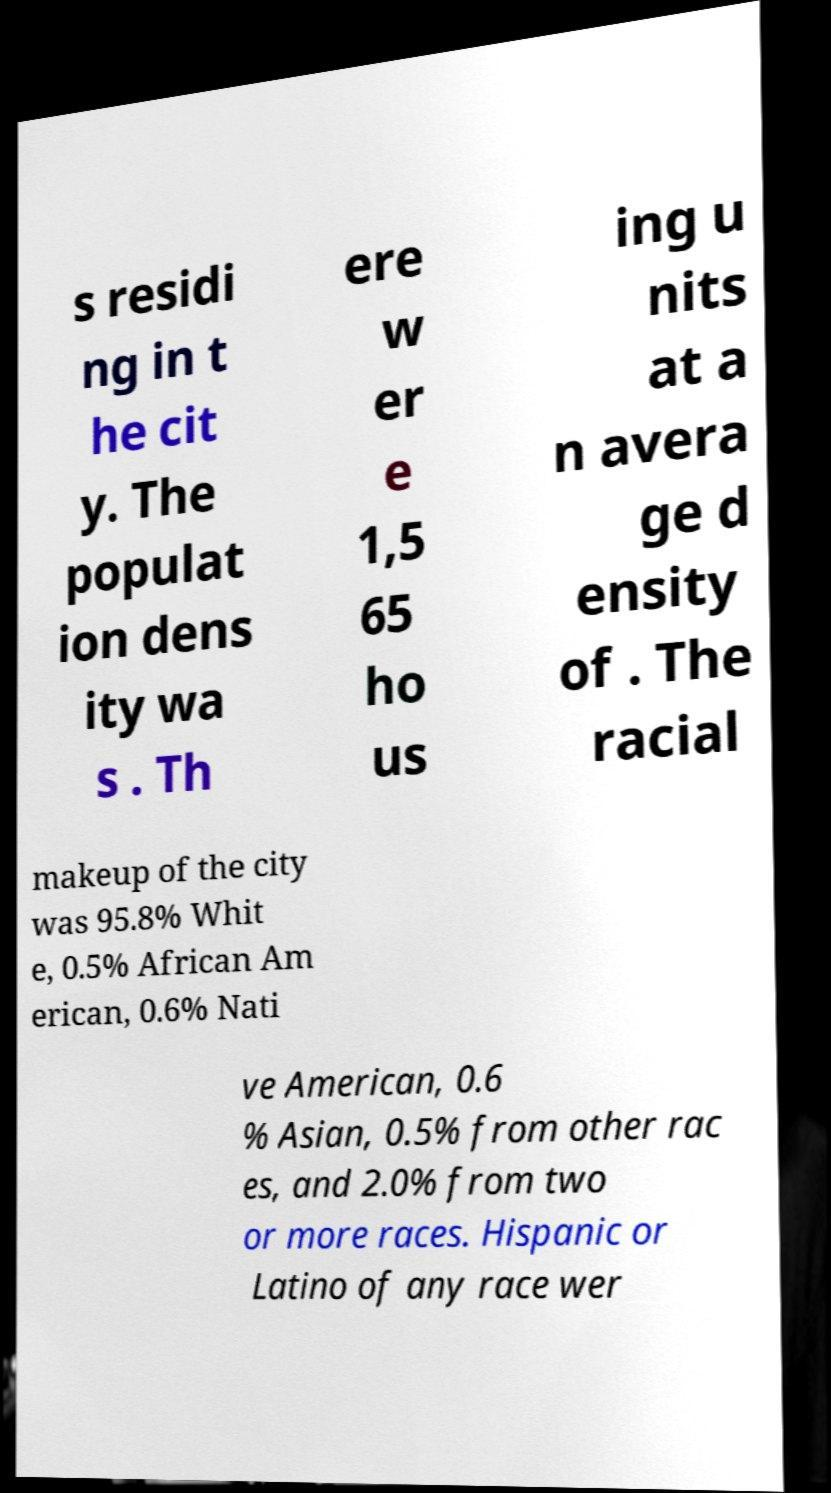I need the written content from this picture converted into text. Can you do that? s residi ng in t he cit y. The populat ion dens ity wa s . Th ere w er e 1,5 65 ho us ing u nits at a n avera ge d ensity of . The racial makeup of the city was 95.8% Whit e, 0.5% African Am erican, 0.6% Nati ve American, 0.6 % Asian, 0.5% from other rac es, and 2.0% from two or more races. Hispanic or Latino of any race wer 